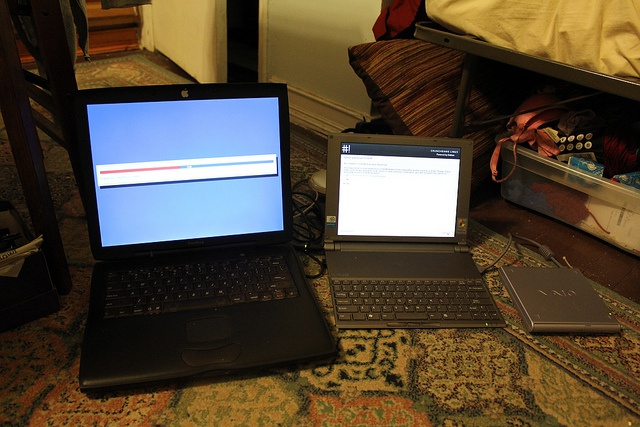Describe the objects in this image and their specific colors. I can see laptop in black and lightblue tones, laptop in black, white, and olive tones, keyboard in black and gray tones, keyboard in black, olive, and gray tones, and laptop in black, maroon, and olive tones in this image. 